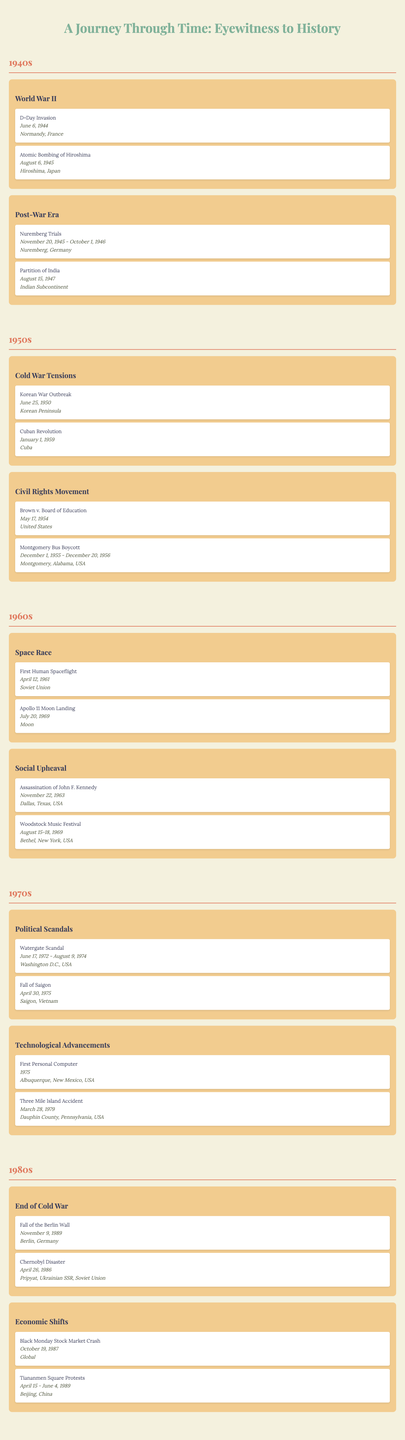What significant event occurred on June 6, 1944? Referring to the 1940s section under World War II, the event listed for this date is the D-Day Invasion.
Answer: D-Day Invasion Which decade did the Watergate Scandal take place? Looking at the timeline, the Watergate Scandal is listed in the 1970s category under Political Scandals.
Answer: 1970s How many major events are listed for the 1960s? In the 1960s section, there are two categories (Space Race and Social Upheaval), with a total of four events (two in each category). Therefore, the count is 4.
Answer: 4 Was the first personal computer event documented in the 1980s? Checking the 1980s section, the First Personal Computer is actually listed in the 1970s category. Therefore, the statement is false.
Answer: No What was the date range for the Nuremberg Trials? The Nuremberg Trials took place from November 20, 1945, to October 1, 1946, as listed in the 1940s category under Post-War Era.
Answer: November 20, 1945 - October 1, 1946 Identify the event associated with April 30, 1975. In the 1970s section, it is noted that the Fall of Saigon occurred on April 30, 1975.
Answer: Fall of Saigon Which event took place in Cuba during the 1950s? According to the 1950s section under Cold War Tensions, the Cuban Revolution occurred on January 1, 1959.
Answer: Cuban Revolution Compare the number of events in the 1980s and the 1940s. The 1980s has four events (two in each category) while the 1940s also has four events (two in each category). Hence, the counts are equal.
Answer: Equal What was the location of the First Human Spaceflight? The table indicates that the First Human Spaceflight took place in the Soviet Union, as stated in the 1960s under the Space Race category.
Answer: Soviet Union Which event was related to the Cold War tensions and began on June 25, 1950? The event that began on June 25, 1950, related to Cold War Tensions is the Korean War Outbreak, as shown in the 1950s section.
Answer: Korean War Outbreak 